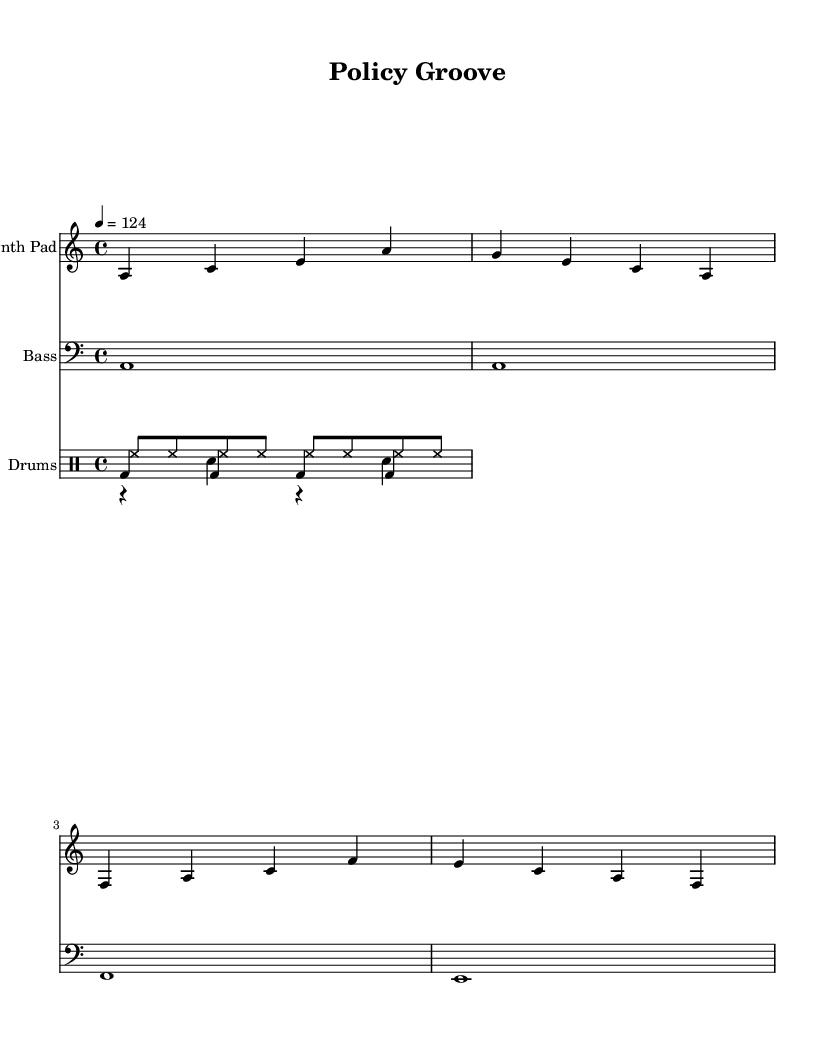What is the key signature of this music? The key signature is A minor, which has no sharps or flats.
Answer: A minor What is the time signature of this piece? The time signature is indicated at the beginning of the score, and it shows four beats per measure.
Answer: 4/4 What tempo marking is used for this piece? The tempo marking indicates a speed of 124 beats per minute, specified in the score.
Answer: 124 How many measures are in the synth pad part? The synth pad part consists of four measures, as indicated by the grouping of notes.
Answer: 4 What is the rhythm pattern of the hi-hat in this piece? The hi-hat part contains a steady eighth-note rhythm, consistently played throughout the measures.
Answer: Eighth notes What type of drum does the kick drum represent? The kick drum plays on each beat of the measure, establishing a solid foundation common in house music.
Answer: Bass drum Which instrument has the longest note value in this score? The bass instrument features a whole note, which has the longest duration compared to other notes in the score.
Answer: Whole note 